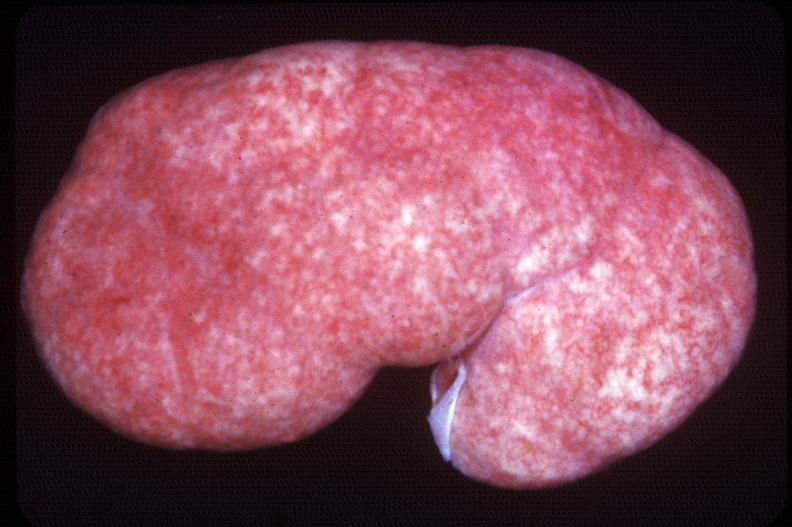does pancreatic islet, amyloidosis diabetes mellitus, congo red show kidney, pyelonephritis, acute and supperative?
Answer the question using a single word or phrase. No 